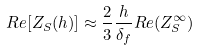Convert formula to latex. <formula><loc_0><loc_0><loc_500><loc_500>R e [ Z _ { S } ( h ) ] \approx \frac { 2 } { 3 } \frac { h } { \delta _ { f } } R e ( Z _ { S } ^ { \infty } )</formula> 